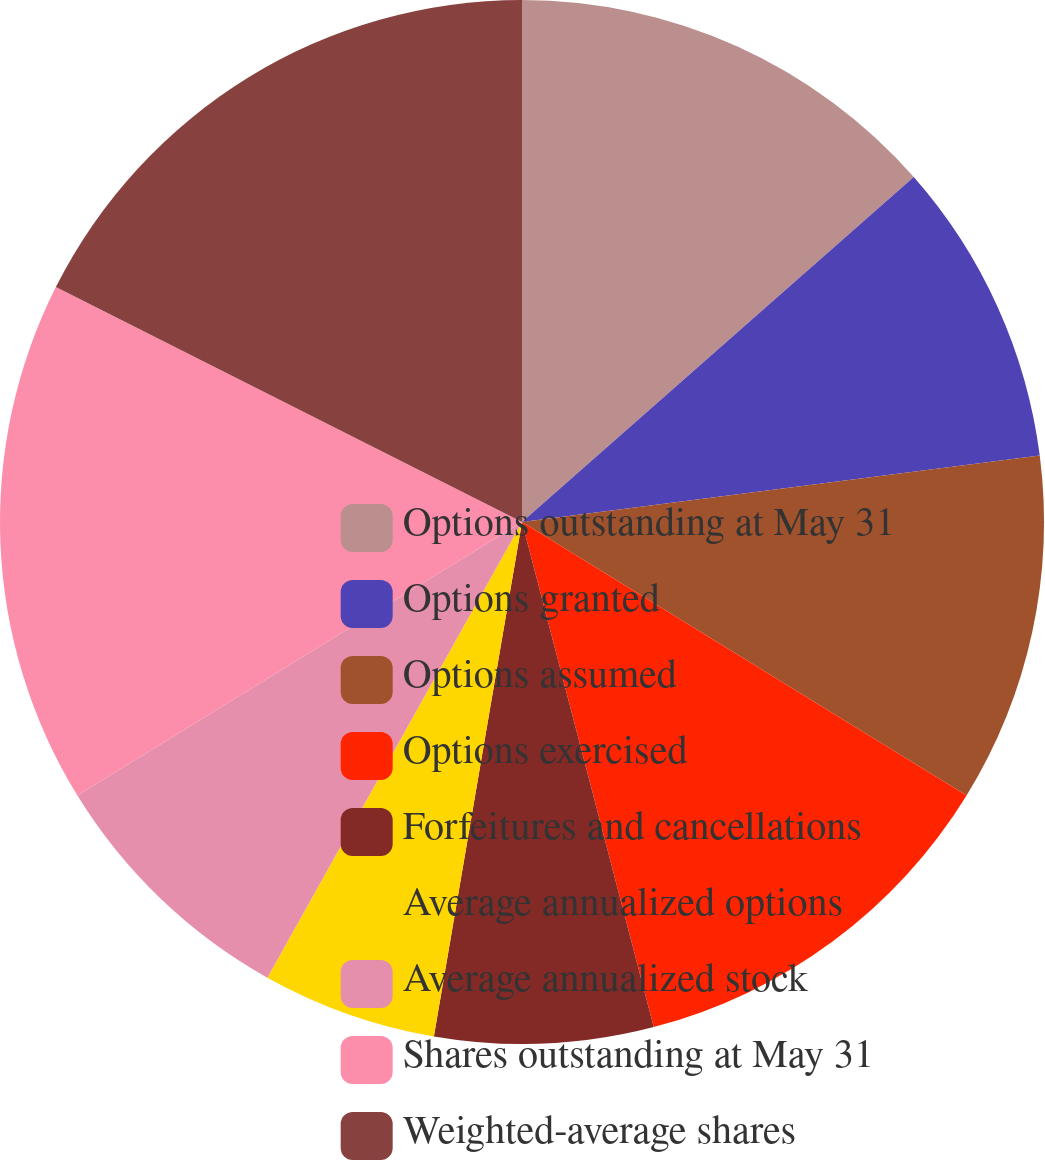<chart> <loc_0><loc_0><loc_500><loc_500><pie_chart><fcel>Options outstanding at May 31<fcel>Options granted<fcel>Options assumed<fcel>Options exercised<fcel>Forfeitures and cancellations<fcel>Average annualized options<fcel>Average annualized stock<fcel>Shares outstanding at May 31<fcel>Weighted-average shares<nl><fcel>13.51%<fcel>9.46%<fcel>10.81%<fcel>12.16%<fcel>6.76%<fcel>5.41%<fcel>8.11%<fcel>16.21%<fcel>17.57%<nl></chart> 